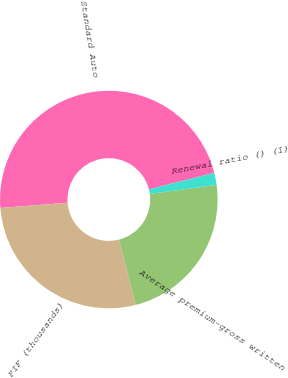<chart> <loc_0><loc_0><loc_500><loc_500><pie_chart><fcel>Standard Auto<fcel>PIF (thousands)<fcel>Average premium-gross written<fcel>Renewal ratio () (1)<nl><fcel>47.3%<fcel>27.73%<fcel>23.18%<fcel>1.8%<nl></chart> 